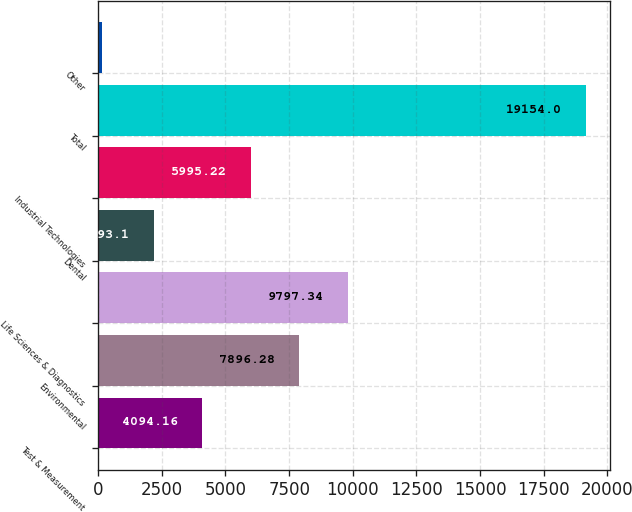<chart> <loc_0><loc_0><loc_500><loc_500><bar_chart><fcel>Test & Measurement<fcel>Environmental<fcel>Life Sciences & Diagnostics<fcel>Dental<fcel>Industrial Technologies<fcel>Total<fcel>Other<nl><fcel>4094.16<fcel>7896.28<fcel>9797.34<fcel>2193.1<fcel>5995.22<fcel>19154<fcel>143.4<nl></chart> 